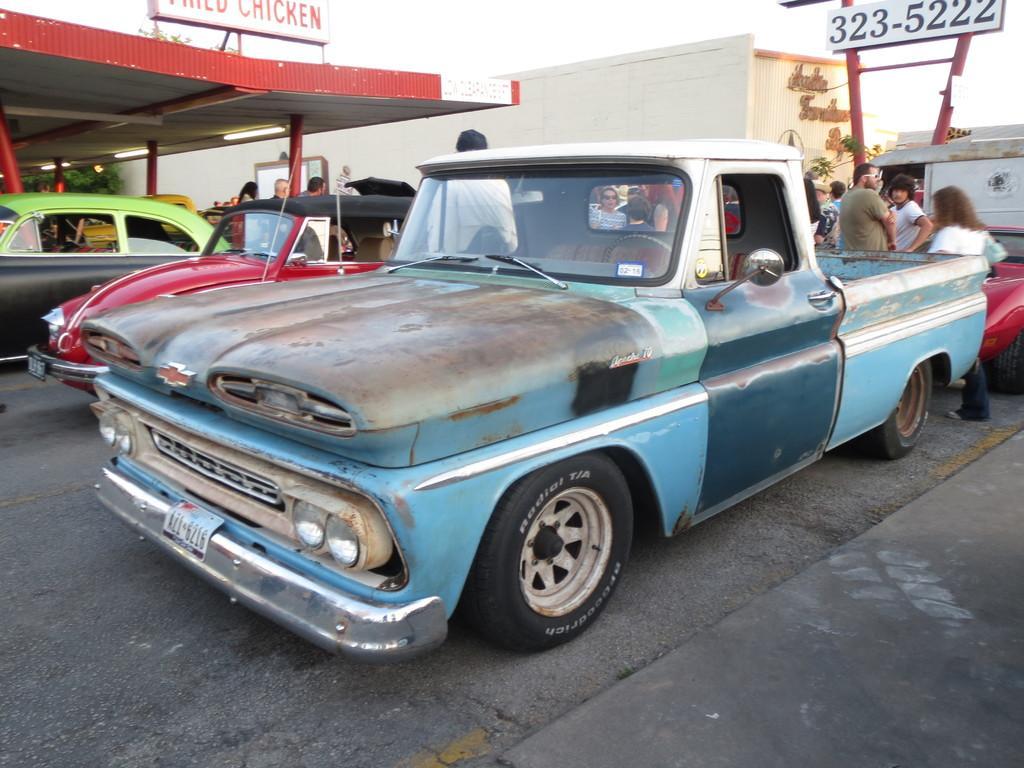Please provide a concise description of this image. In the center of the image there is a car on the road. In the background we can see persons, cars, poles, buildings, advertisement and sky. 